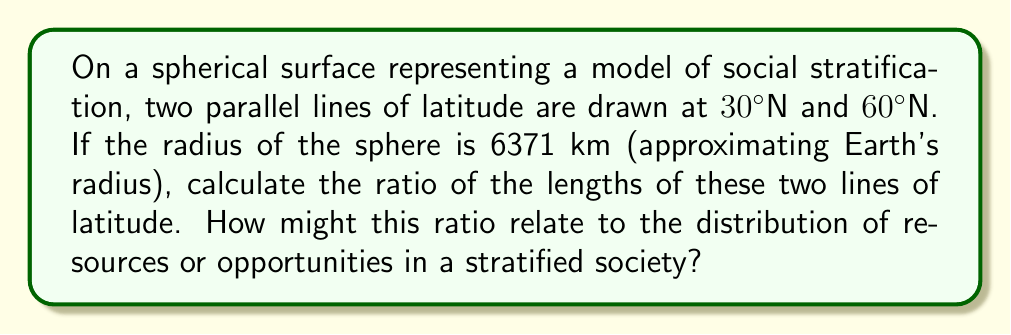Could you help me with this problem? Let's approach this step-by-step:

1) On a sphere, lines of latitude are circles parallel to the equator. Their circumference depends on their distance from the equator.

2) The radius of a circle of latitude at angle $\theta$ from the equator is given by:
   $r = R \cos(\theta)$, where $R$ is the radius of the sphere.

3) For $30°N$:
   $r_{30} = 6371 \cos(30°) = 6371 \cdot \frac{\sqrt{3}}{2} \approx 5518.20$ km

4) For $60°N$:
   $r_{60} = 6371 \cos(60°) = 6371 \cdot \frac{1}{2} \approx 3185.50$ km

5) The circumference of each circle is given by $C = 2\pi r$. The ratio of their lengths will be the same as the ratio of their radii:

   $$\frac{C_{30}}{C_{60}} = \frac{2\pi r_{30}}{2\pi r_{60}} = \frac{r_{30}}{r_{60}} = \frac{6371 \cos(30°)}{6371 \cos(60°)} = \frac{\cos(30°)}{\cos(60°)} = \frac{\sqrt{3}}{2} \div \frac{1}{2} = \sqrt{3} \approx 1.732$$

6) This ratio suggests that the circle at $30°N$ is approximately 1.732 times longer than the circle at $60°N$.

In terms of social stratification, this ratio could represent the distribution of resources or opportunities at different social levels. The longer circumference at $30°N$ might symbolize a broader middle class with more diverse opportunities, while the shorter circumference at $60°N$ could represent a more concentrated upper class with fewer but potentially more valuable resources.
Answer: $\sqrt{3} \approx 1.732$ 